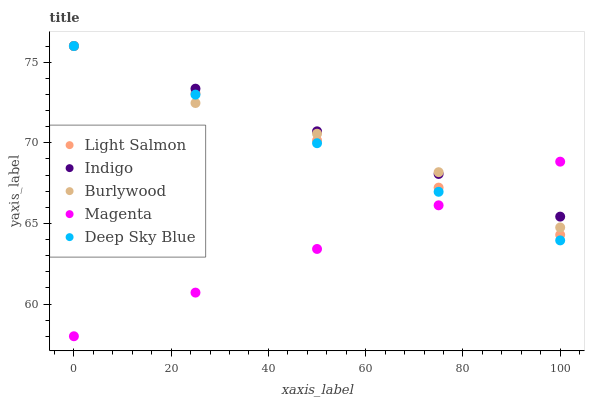Does Magenta have the minimum area under the curve?
Answer yes or no. Yes. Does Indigo have the maximum area under the curve?
Answer yes or no. Yes. Does Light Salmon have the minimum area under the curve?
Answer yes or no. No. Does Light Salmon have the maximum area under the curve?
Answer yes or no. No. Is Indigo the smoothest?
Answer yes or no. Yes. Is Burlywood the roughest?
Answer yes or no. Yes. Is Light Salmon the smoothest?
Answer yes or no. No. Is Light Salmon the roughest?
Answer yes or no. No. Does Magenta have the lowest value?
Answer yes or no. Yes. Does Light Salmon have the lowest value?
Answer yes or no. No. Does Deep Sky Blue have the highest value?
Answer yes or no. Yes. Does Magenta have the highest value?
Answer yes or no. No. Does Indigo intersect Light Salmon?
Answer yes or no. Yes. Is Indigo less than Light Salmon?
Answer yes or no. No. Is Indigo greater than Light Salmon?
Answer yes or no. No. 